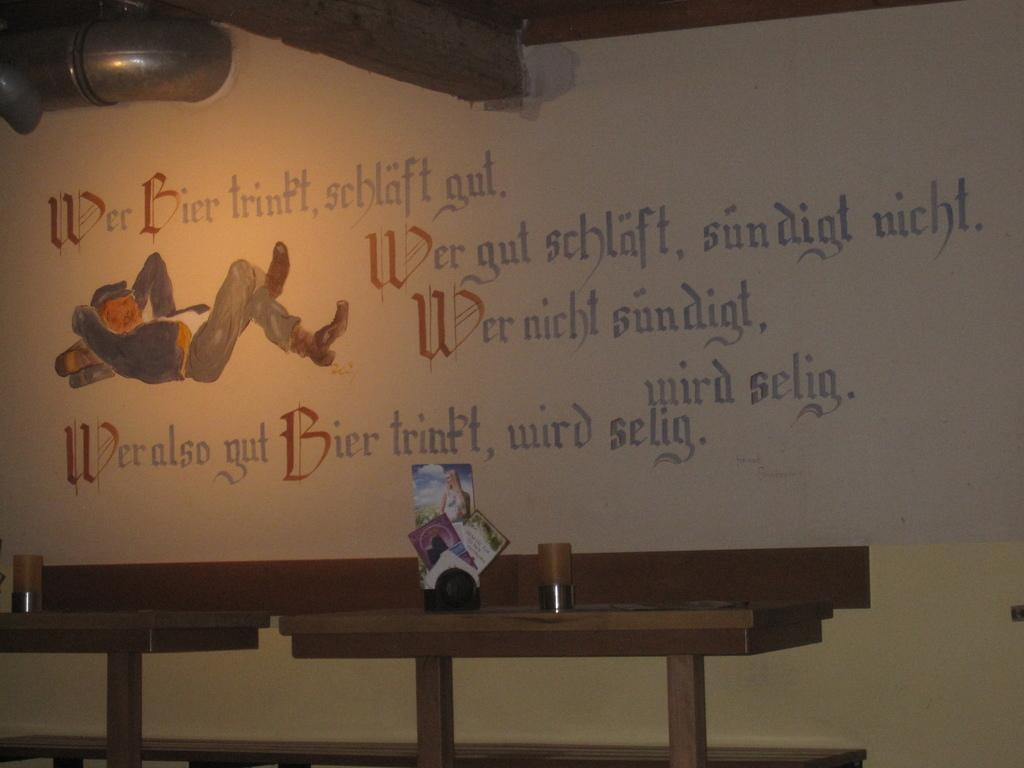What type of furniture can be seen in the image? There are tables in the image. What is placed on the tables? There are items on the tables. What can be seen in the background of the image? There is a wall in the background of the image. What is written on the wall? Something is written on the wall. What type of artwork is present on the wall? There is a painting of a person lying on the wall. How many ducks can be seen swimming in the hole in the image? There are no ducks or holes present in the image. 